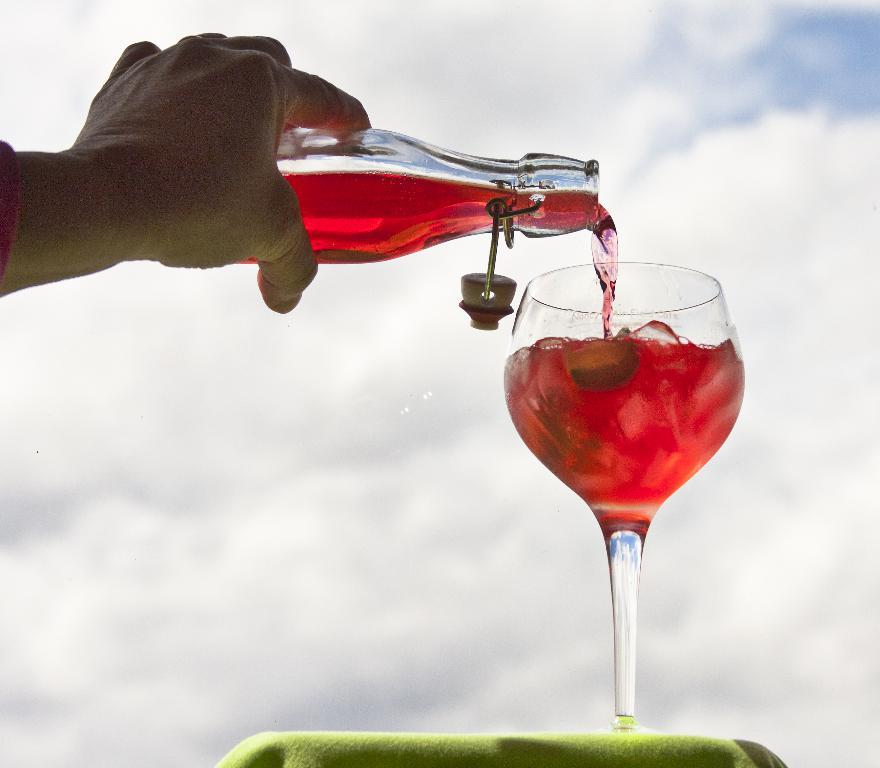What is the person holding in the image? The person is holding a glass bottle with a drink. What type of glassware is present on the green cloth? There is a wine glass on a green cloth. What can be seen in the background of the image? The background of the image includes clouds. What part of the natural environment is visible in the image? The sky is visible in the background of the image. What type of cheese is being used to tie up the sheep in the image? There are no cheese or sheep present in the image. 